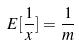<formula> <loc_0><loc_0><loc_500><loc_500>E [ \frac { 1 } { x } ] = \frac { 1 } { m }</formula> 